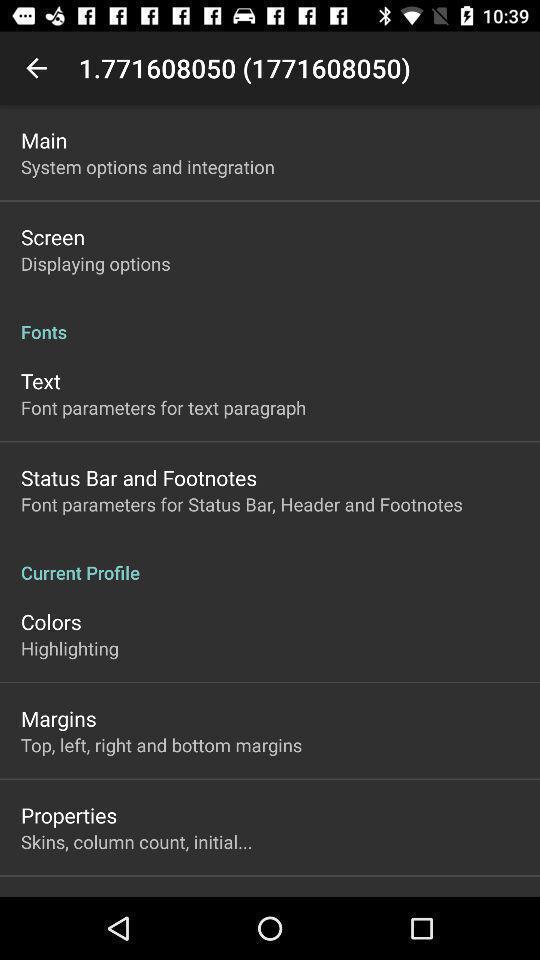What can you discern from this picture? Screen shows multiple options in a books application. 